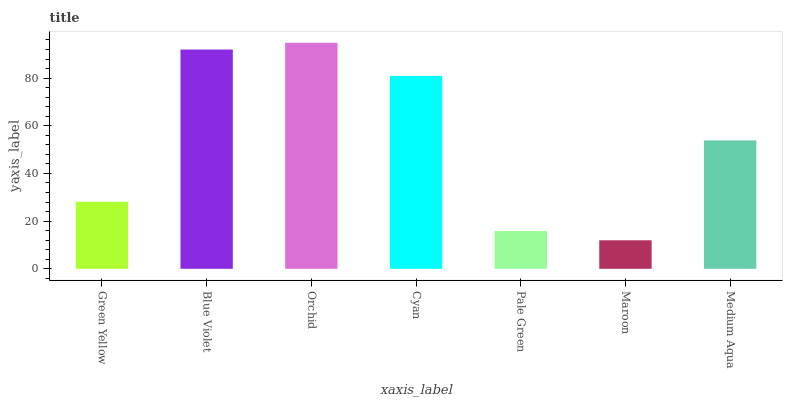Is Maroon the minimum?
Answer yes or no. Yes. Is Orchid the maximum?
Answer yes or no. Yes. Is Blue Violet the minimum?
Answer yes or no. No. Is Blue Violet the maximum?
Answer yes or no. No. Is Blue Violet greater than Green Yellow?
Answer yes or no. Yes. Is Green Yellow less than Blue Violet?
Answer yes or no. Yes. Is Green Yellow greater than Blue Violet?
Answer yes or no. No. Is Blue Violet less than Green Yellow?
Answer yes or no. No. Is Medium Aqua the high median?
Answer yes or no. Yes. Is Medium Aqua the low median?
Answer yes or no. Yes. Is Green Yellow the high median?
Answer yes or no. No. Is Orchid the low median?
Answer yes or no. No. 